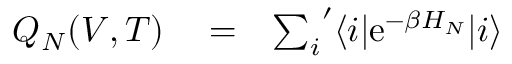<formula> <loc_0><loc_0><loc_500><loc_500>\begin{array} { r l r } { Q _ { N } ( V , T ) } & = } & { { \sum _ { i } } ^ { \prime } \langle i | e ^ { - \beta H _ { N } } | i \rangle } \end{array}</formula> 